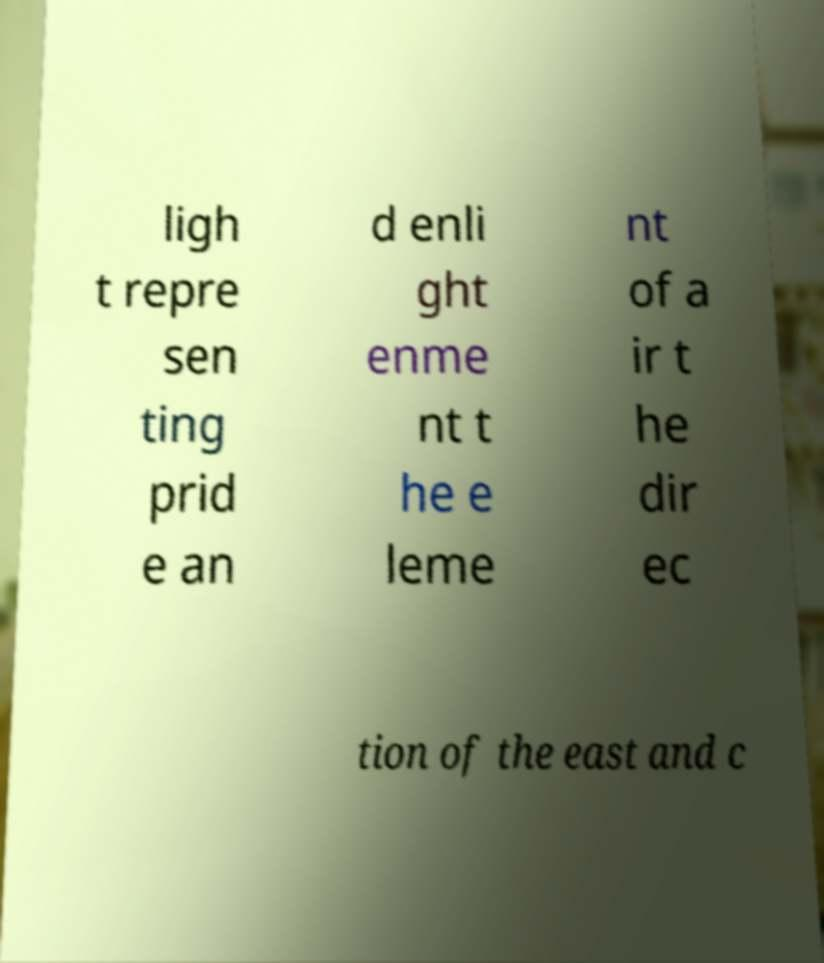I need the written content from this picture converted into text. Can you do that? ligh t repre sen ting prid e an d enli ght enme nt t he e leme nt of a ir t he dir ec tion of the east and c 